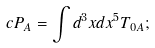<formula> <loc_0><loc_0><loc_500><loc_500>c P _ { A } = \int d ^ { 3 } x d x ^ { 5 } T _ { 0 A } ;</formula> 